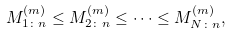<formula> <loc_0><loc_0><loc_500><loc_500>M _ { 1 \colon n } ^ { ( m ) } \leq M _ { 2 \colon n } ^ { ( m ) } \leq \cdots \leq M _ { N \colon n } ^ { ( m ) } ,</formula> 